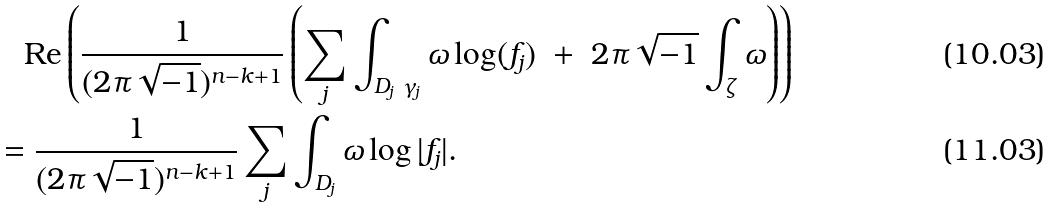<formula> <loc_0><loc_0><loc_500><loc_500>& \quad \text {Re} \left ( \frac { 1 } { ( 2 \pi \sqrt { - 1 } ) ^ { n - k + 1 } } \left ( \sum _ { j } \int _ { D _ { j } \ \gamma _ { j } } \omega \log ( f _ { j } ) \ + \ 2 \pi \sqrt { - 1 } \int _ { \zeta } \omega \right ) \right ) \\ & = \frac { 1 } { ( 2 \pi \sqrt { - 1 } ) ^ { n - k + 1 } } \sum _ { j } \int _ { D _ { j } } \omega \log | f _ { j } | .</formula> 